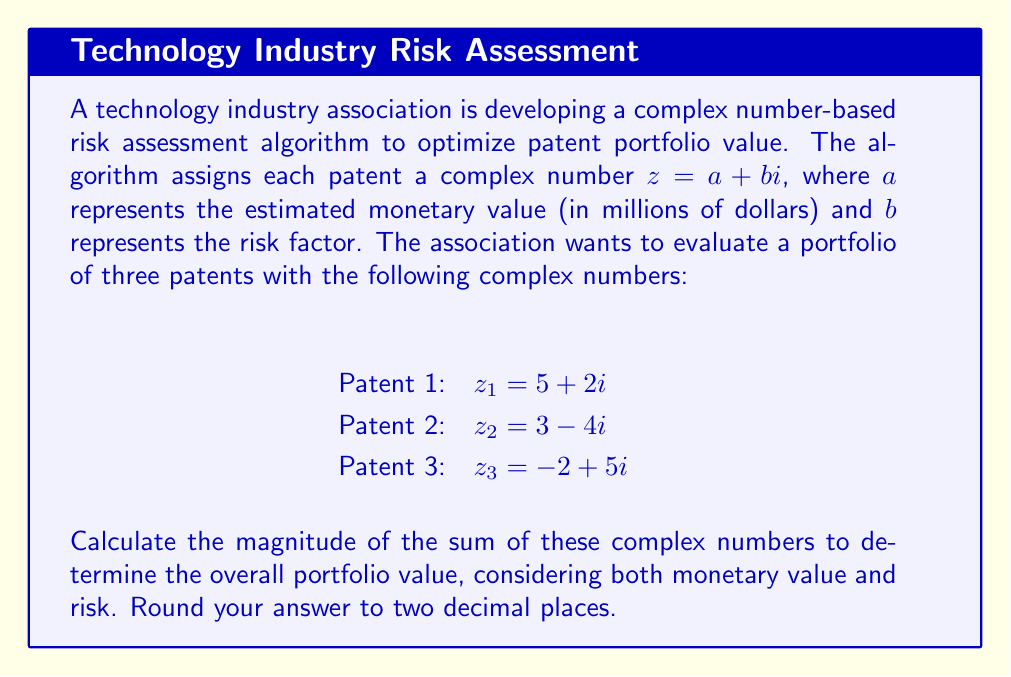Provide a solution to this math problem. To solve this problem, we need to follow these steps:

1. Sum the complex numbers representing the patents:
   $$z_{total} = z_1 + z_2 + z_3$$
   $$z_{total} = (5 + 2i) + (3 - 4i) + (-2 + 5i)$$
   $$z_{total} = (5 + 3 - 2) + (2 - 4 + 5)i$$
   $$z_{total} = 6 + 3i$$

2. Calculate the magnitude of the resulting complex number:
   The magnitude of a complex number $z = a + bi$ is given by the formula:
   $$|z| = \sqrt{a^2 + b^2}$$

   For our total complex number $z_{total} = 6 + 3i$:
   $$|z_{total}| = \sqrt{6^2 + 3^2}$$
   $$|z_{total}| = \sqrt{36 + 9}$$
   $$|z_{total}| = \sqrt{45}$$
   $$|z_{total}| \approx 6.7082$$

3. Round the result to two decimal places:
   $$|z_{total}| \approx 6.71$$

This magnitude represents the overall portfolio value, taking into account both the monetary value and the risk factor of all three patents.
Answer: $6.71$ 